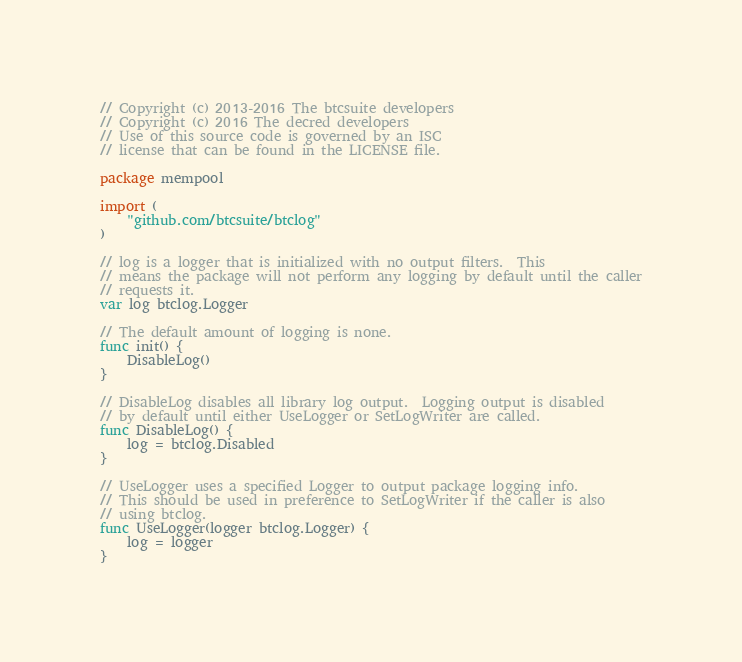Convert code to text. <code><loc_0><loc_0><loc_500><loc_500><_Go_>// Copyright (c) 2013-2016 The btcsuite developers
// Copyright (c) 2016 The decred developers
// Use of this source code is governed by an ISC
// license that can be found in the LICENSE file.

package mempool

import (
	"github.com/btcsuite/btclog"
)

// log is a logger that is initialized with no output filters.  This
// means the package will not perform any logging by default until the caller
// requests it.
var log btclog.Logger

// The default amount of logging is none.
func init() {
	DisableLog()
}

// DisableLog disables all library log output.  Logging output is disabled
// by default until either UseLogger or SetLogWriter are called.
func DisableLog() {
	log = btclog.Disabled
}

// UseLogger uses a specified Logger to output package logging info.
// This should be used in preference to SetLogWriter if the caller is also
// using btclog.
func UseLogger(logger btclog.Logger) {
	log = logger
}
</code> 